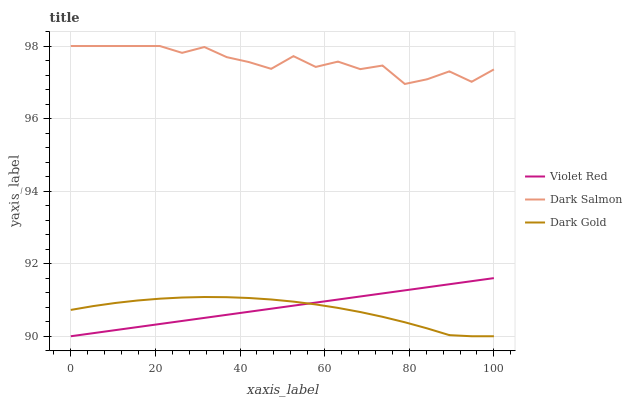Does Dark Gold have the minimum area under the curve?
Answer yes or no. Yes. Does Dark Salmon have the maximum area under the curve?
Answer yes or no. Yes. Does Dark Salmon have the minimum area under the curve?
Answer yes or no. No. Does Dark Gold have the maximum area under the curve?
Answer yes or no. No. Is Violet Red the smoothest?
Answer yes or no. Yes. Is Dark Salmon the roughest?
Answer yes or no. Yes. Is Dark Gold the smoothest?
Answer yes or no. No. Is Dark Gold the roughest?
Answer yes or no. No. Does Violet Red have the lowest value?
Answer yes or no. Yes. Does Dark Salmon have the lowest value?
Answer yes or no. No. Does Dark Salmon have the highest value?
Answer yes or no. Yes. Does Dark Gold have the highest value?
Answer yes or no. No. Is Dark Gold less than Dark Salmon?
Answer yes or no. Yes. Is Dark Salmon greater than Dark Gold?
Answer yes or no. Yes. Does Dark Gold intersect Violet Red?
Answer yes or no. Yes. Is Dark Gold less than Violet Red?
Answer yes or no. No. Is Dark Gold greater than Violet Red?
Answer yes or no. No. Does Dark Gold intersect Dark Salmon?
Answer yes or no. No. 